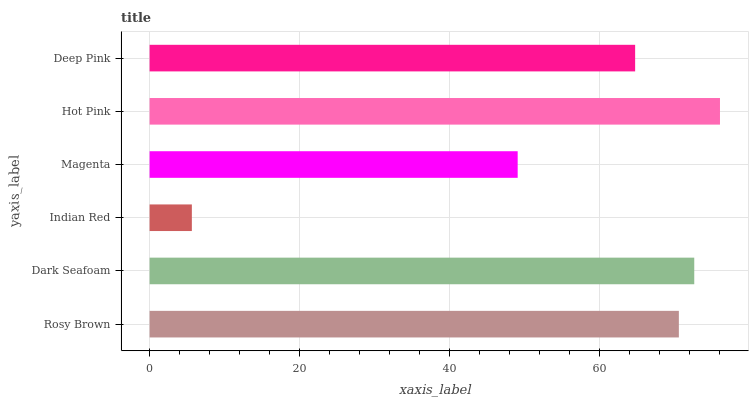Is Indian Red the minimum?
Answer yes or no. Yes. Is Hot Pink the maximum?
Answer yes or no. Yes. Is Dark Seafoam the minimum?
Answer yes or no. No. Is Dark Seafoam the maximum?
Answer yes or no. No. Is Dark Seafoam greater than Rosy Brown?
Answer yes or no. Yes. Is Rosy Brown less than Dark Seafoam?
Answer yes or no. Yes. Is Rosy Brown greater than Dark Seafoam?
Answer yes or no. No. Is Dark Seafoam less than Rosy Brown?
Answer yes or no. No. Is Rosy Brown the high median?
Answer yes or no. Yes. Is Deep Pink the low median?
Answer yes or no. Yes. Is Hot Pink the high median?
Answer yes or no. No. Is Hot Pink the low median?
Answer yes or no. No. 